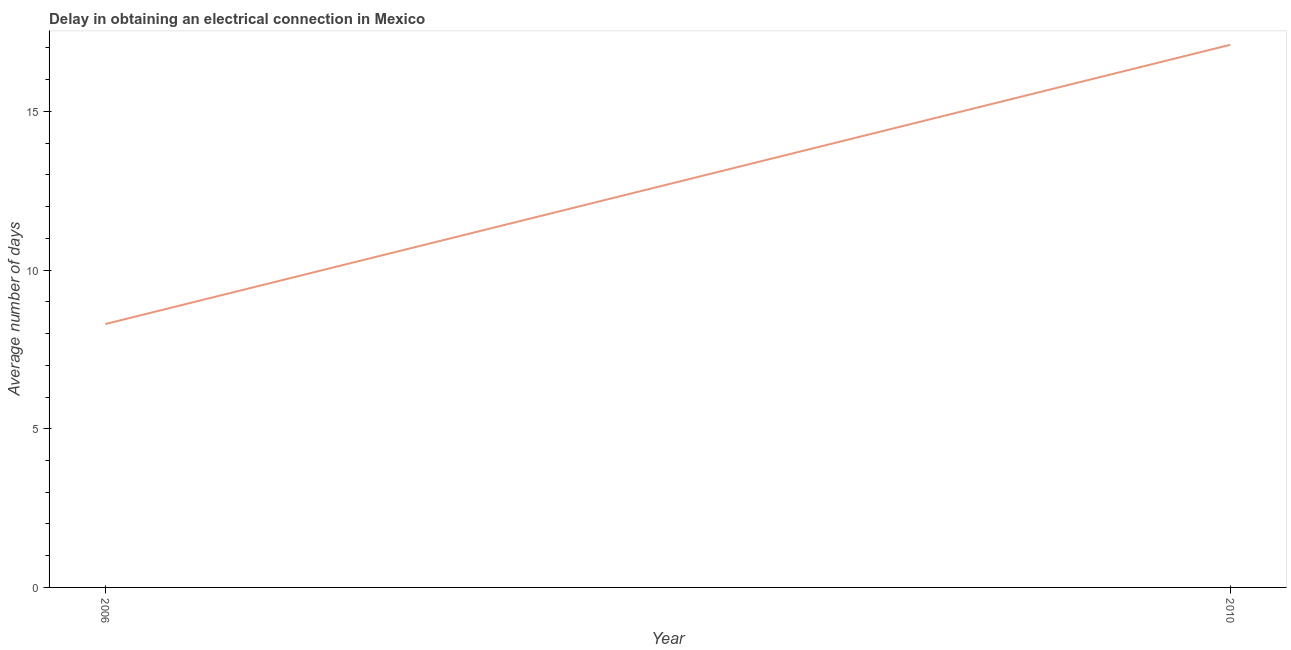Across all years, what is the minimum dalay in electrical connection?
Ensure brevity in your answer.  8.3. In which year was the dalay in electrical connection minimum?
Offer a terse response. 2006. What is the sum of the dalay in electrical connection?
Keep it short and to the point. 25.4. What is the average dalay in electrical connection per year?
Ensure brevity in your answer.  12.7. What is the median dalay in electrical connection?
Your answer should be compact. 12.7. In how many years, is the dalay in electrical connection greater than 13 days?
Keep it short and to the point. 1. Do a majority of the years between 2010 and 2006 (inclusive) have dalay in electrical connection greater than 14 days?
Offer a terse response. No. What is the ratio of the dalay in electrical connection in 2006 to that in 2010?
Your response must be concise. 0.49. Is the dalay in electrical connection in 2006 less than that in 2010?
Give a very brief answer. Yes. Does the dalay in electrical connection monotonically increase over the years?
Your answer should be compact. Yes. How many lines are there?
Make the answer very short. 1. How many years are there in the graph?
Keep it short and to the point. 2. What is the title of the graph?
Your response must be concise. Delay in obtaining an electrical connection in Mexico. What is the label or title of the Y-axis?
Give a very brief answer. Average number of days. What is the ratio of the Average number of days in 2006 to that in 2010?
Provide a short and direct response. 0.48. 